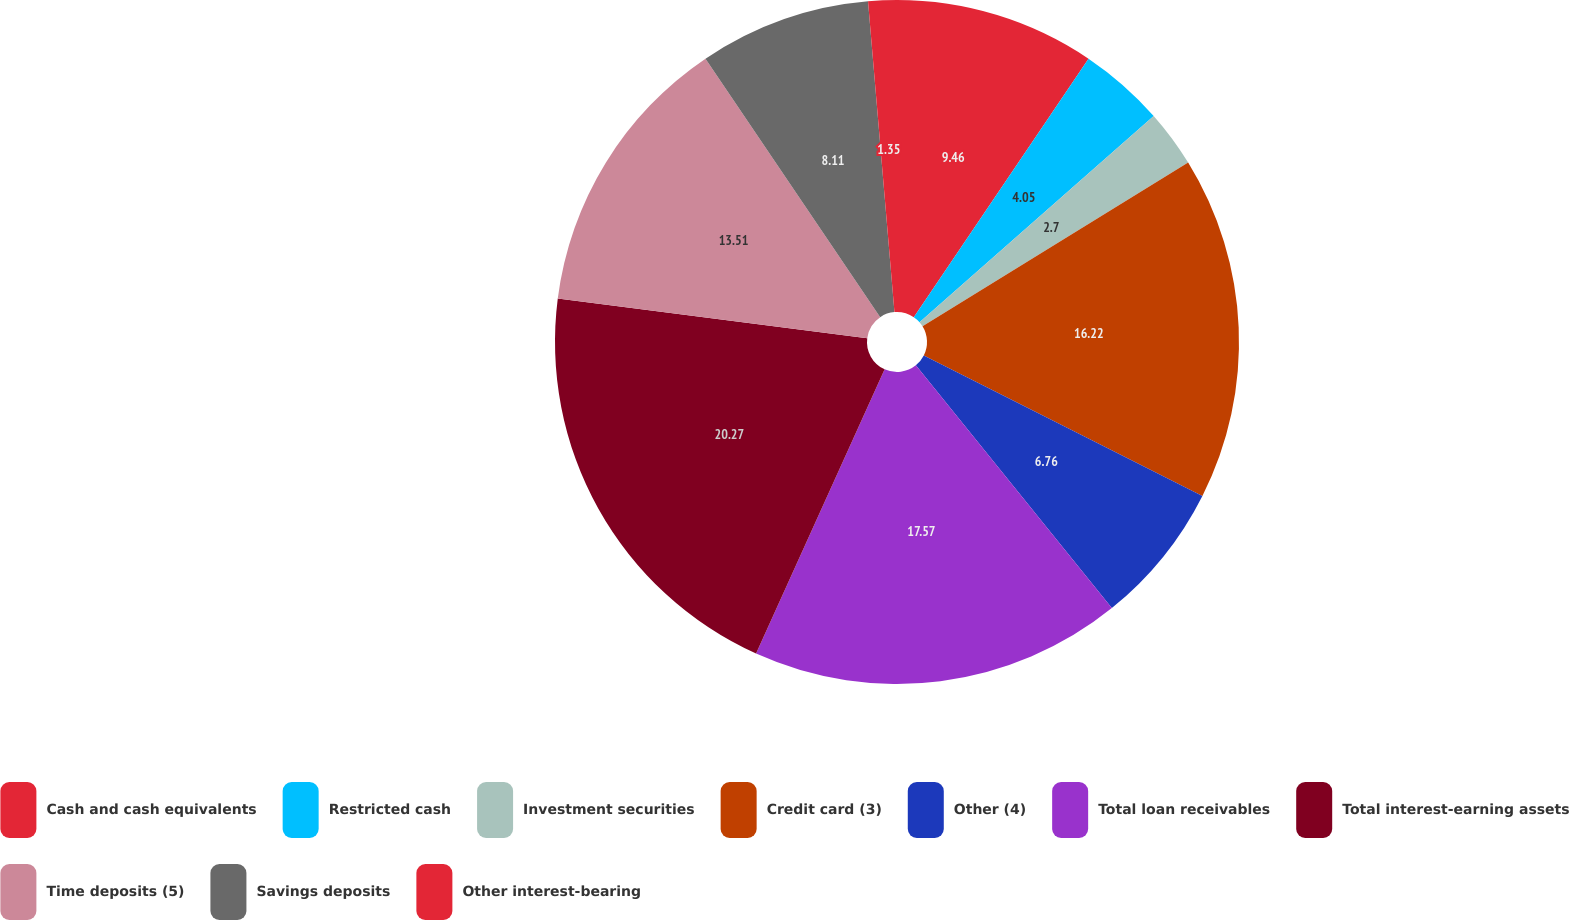<chart> <loc_0><loc_0><loc_500><loc_500><pie_chart><fcel>Cash and cash equivalents<fcel>Restricted cash<fcel>Investment securities<fcel>Credit card (3)<fcel>Other (4)<fcel>Total loan receivables<fcel>Total interest-earning assets<fcel>Time deposits (5)<fcel>Savings deposits<fcel>Other interest-bearing<nl><fcel>9.46%<fcel>4.05%<fcel>2.7%<fcel>16.22%<fcel>6.76%<fcel>17.57%<fcel>20.27%<fcel>13.51%<fcel>8.11%<fcel>1.35%<nl></chart> 